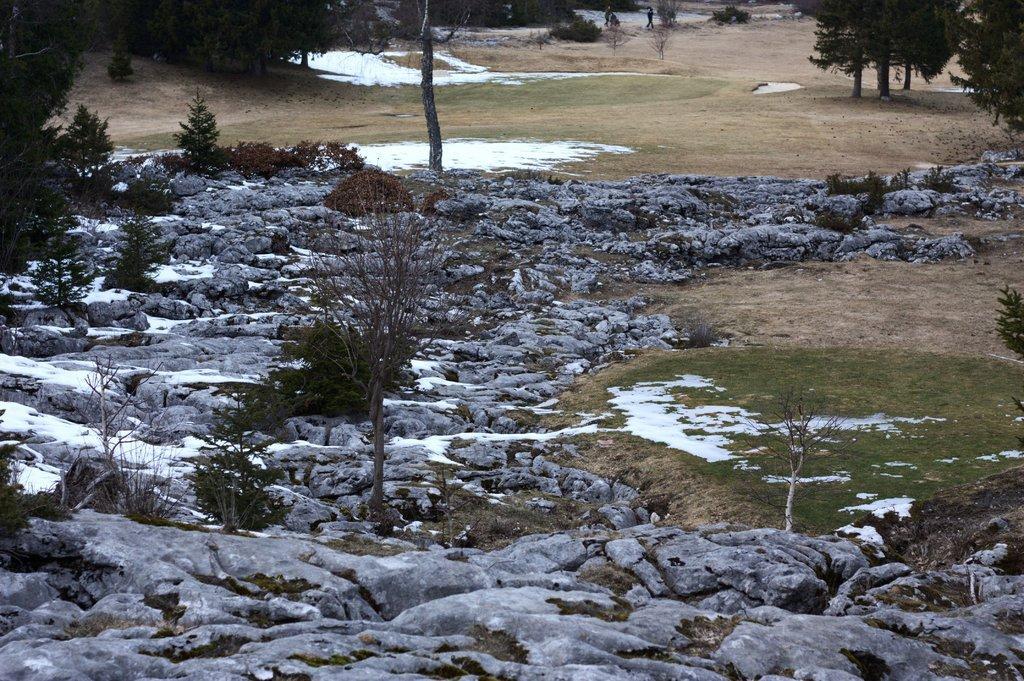How would you summarize this image in a sentence or two? At the bottom of the image there are many rocks with snow on it. And also there are plants, trees and also there is grass on it. At the top of the image there is snow on the few places of the ground. Also there are few trees on the ground. 